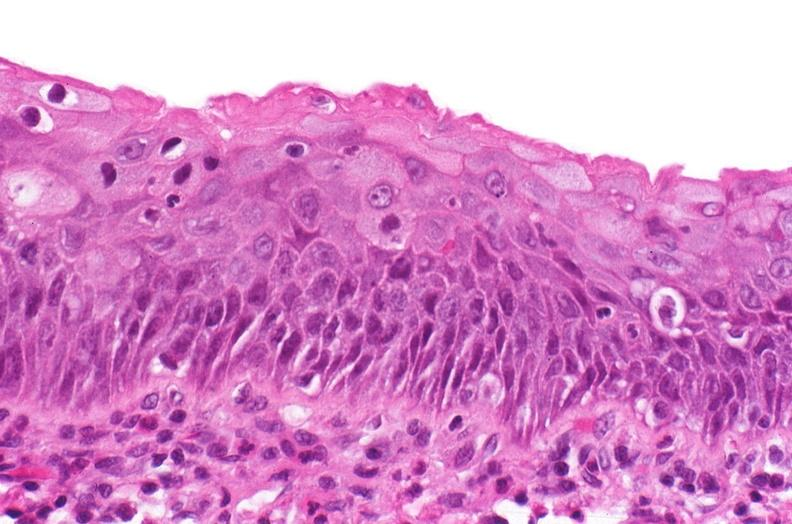s urinary present?
Answer the question using a single word or phrase. Yes 